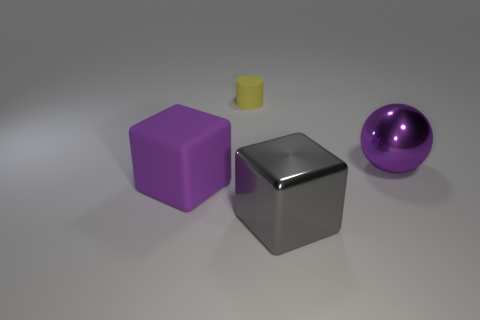What is the material of the other thing that is the same shape as the large matte thing?
Offer a terse response. Metal. Are there any metallic blocks in front of the large object in front of the purple thing that is to the left of the small yellow rubber cylinder?
Your response must be concise. No. Does the matte thing that is behind the purple rubber thing have the same shape as the big purple object to the left of the gray shiny object?
Your response must be concise. No. Are there more purple cubes to the right of the purple rubber cube than purple blocks?
Make the answer very short. No. How many objects are either purple spheres or tiny green rubber objects?
Your answer should be compact. 1. What is the color of the metal block?
Make the answer very short. Gray. How many other things are there of the same color as the rubber block?
Give a very brief answer. 1. Are there any large purple metallic spheres on the left side of the small matte object?
Provide a short and direct response. No. There is a large metallic thing in front of the large purple thing that is behind the large purple object to the left of the gray cube; what color is it?
Ensure brevity in your answer.  Gray. How many things are both behind the purple matte block and to the right of the yellow cylinder?
Your answer should be compact. 1. 